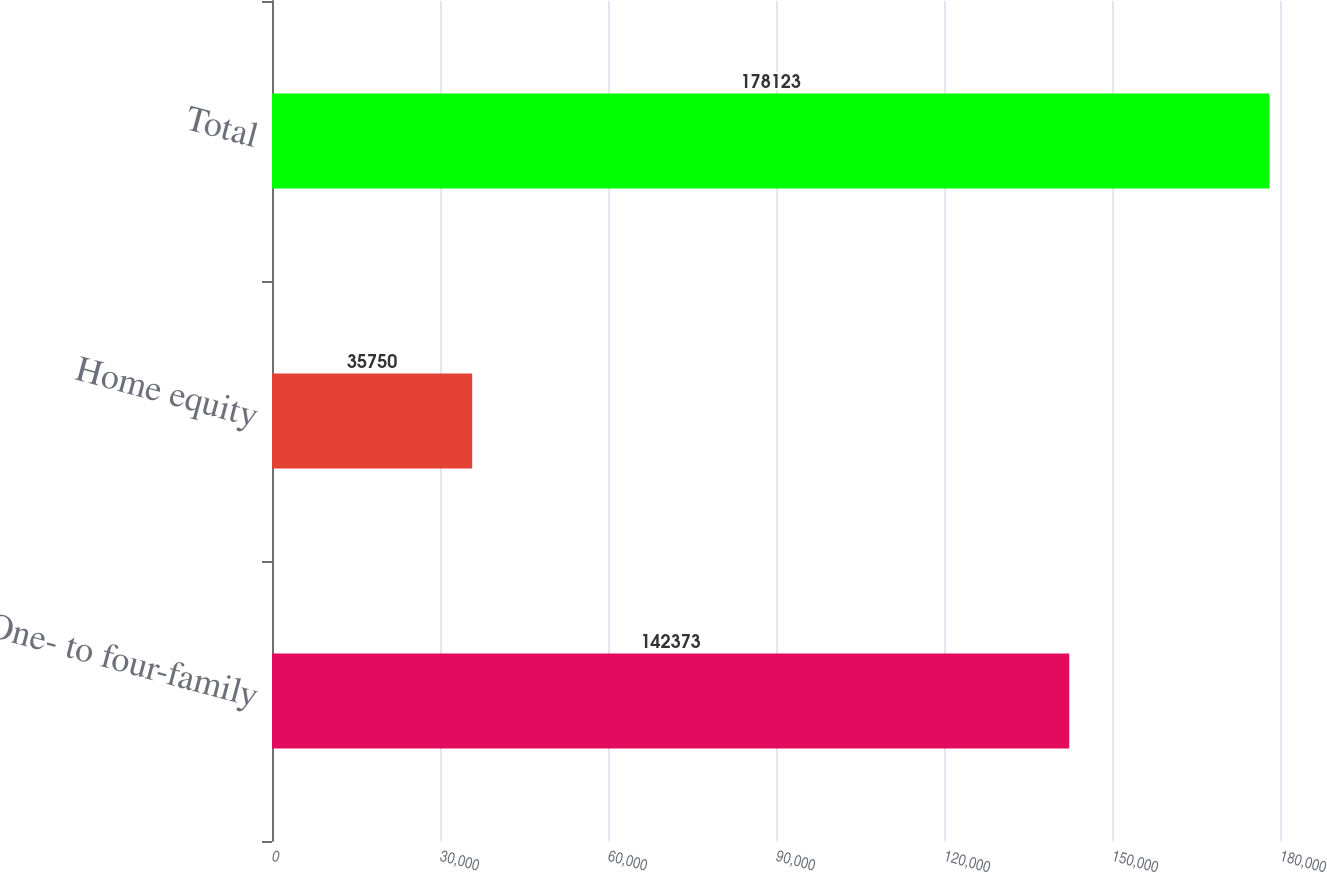<chart> <loc_0><loc_0><loc_500><loc_500><bar_chart><fcel>One- to four-family<fcel>Home equity<fcel>Total<nl><fcel>142373<fcel>35750<fcel>178123<nl></chart> 